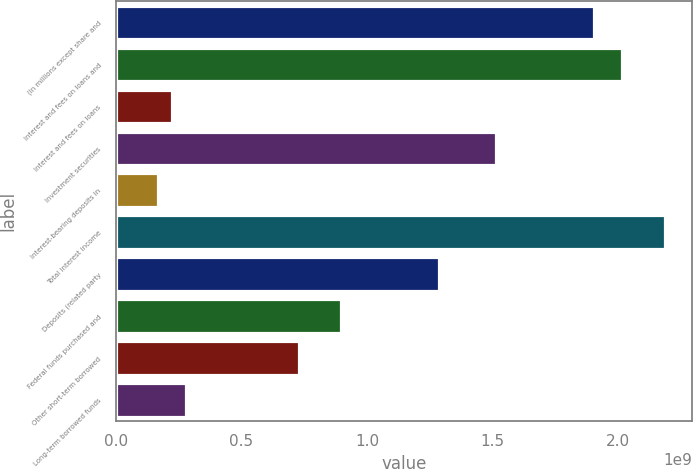Convert chart. <chart><loc_0><loc_0><loc_500><loc_500><bar_chart><fcel>(in millions except share and<fcel>Interest and fees on loans and<fcel>Interest and fees on loans<fcel>Investment securities<fcel>Interest-bearing deposits in<fcel>Total interest income<fcel>Deposits (related party<fcel>Federal funds purchased and<fcel>Other short-term borrowed<fcel>Long-term borrowed funds<nl><fcel>1.90399e+09<fcel>2.01599e+09<fcel>2.23999e+08<fcel>1.512e+09<fcel>1.67999e+08<fcel>2.18399e+09<fcel>1.288e+09<fcel>8.95997e+08<fcel>7.27998e+08<fcel>2.79999e+08<nl></chart> 